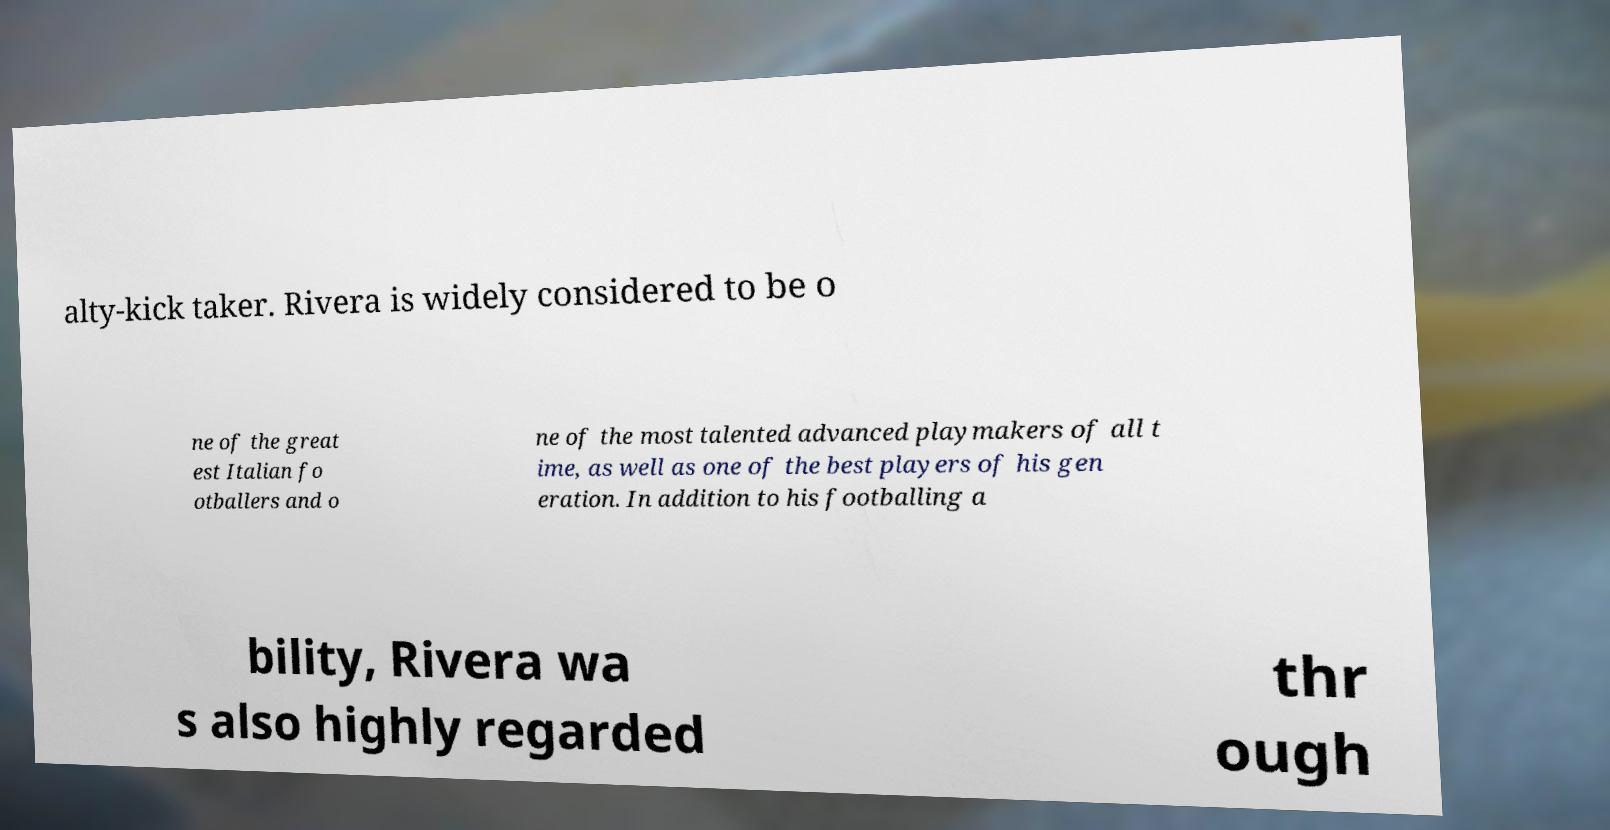Can you accurately transcribe the text from the provided image for me? alty-kick taker. Rivera is widely considered to be o ne of the great est Italian fo otballers and o ne of the most talented advanced playmakers of all t ime, as well as one of the best players of his gen eration. In addition to his footballing a bility, Rivera wa s also highly regarded thr ough 